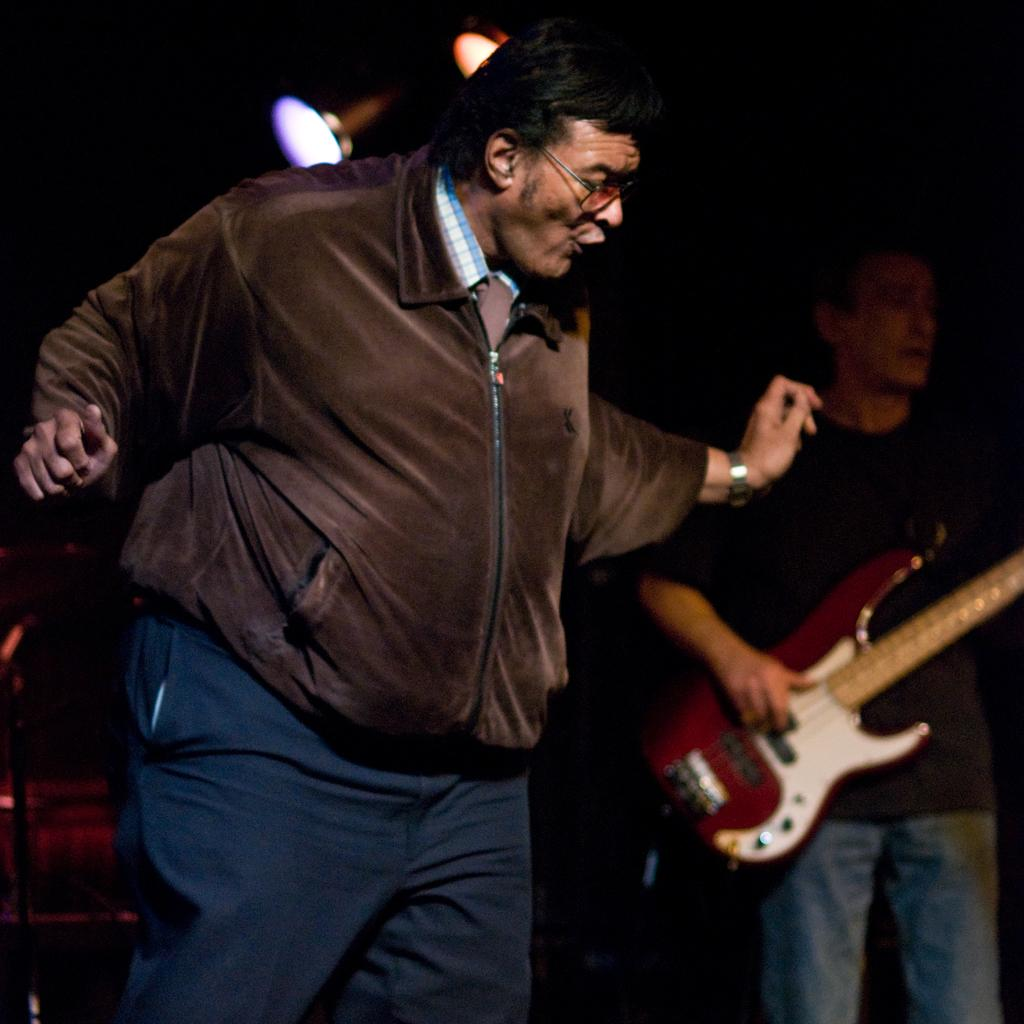How many men are in the image? There are two men in the image. What is the man on the left side doing? The man on the left side is dancing. What is the man on the left side wearing? The man on the left side is wearing a jacket. What is the man on the right side holding? The man on the right side is holding a guitar. What can be seen in the image that provides illumination? There are lights visible in the image. What type of sugar is being used to draw on the chalkboard in the image? There is no chalkboard or sugar present in the image. What is the man on the left side afraid of in the image? There is no indication of fear in the image; the man on the left side is dancing. 